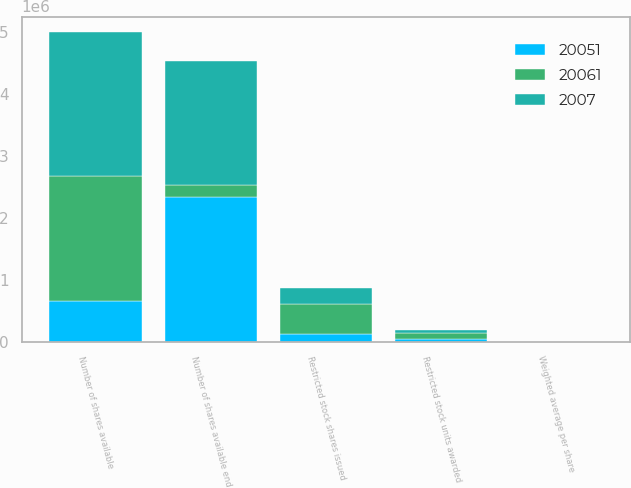Convert chart to OTSL. <chart><loc_0><loc_0><loc_500><loc_500><stacked_bar_chart><ecel><fcel>Number of shares available<fcel>Restricted stock shares issued<fcel>Restricted stock units awarded<fcel>Number of shares available end<fcel>Weighted average per share<nl><fcel>20061<fcel>2.00915e+06<fcel>474100<fcel>95900<fcel>199725<fcel>30.54<nl><fcel>2007<fcel>2.33235e+06<fcel>271350<fcel>56600<fcel>2.00915e+06<fcel>56.46<nl><fcel>20051<fcel>663320<fcel>128100<fcel>39550<fcel>2.33235e+06<fcel>51.07<nl></chart> 